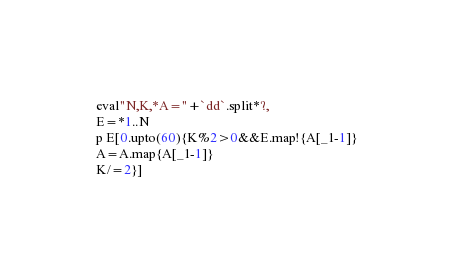Convert code to text. <code><loc_0><loc_0><loc_500><loc_500><_Ruby_>eval"N,K,*A="+`dd`.split*?,
E=*1..N
p E[0.upto(60){K%2>0&&E.map!{A[_1-1]}
A=A.map{A[_1-1]}
K/=2}]</code> 